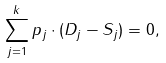<formula> <loc_0><loc_0><loc_500><loc_500>\sum _ { j = 1 } ^ { k } p _ { j } \cdot ( D _ { j } - S _ { j } ) = 0 ,</formula> 